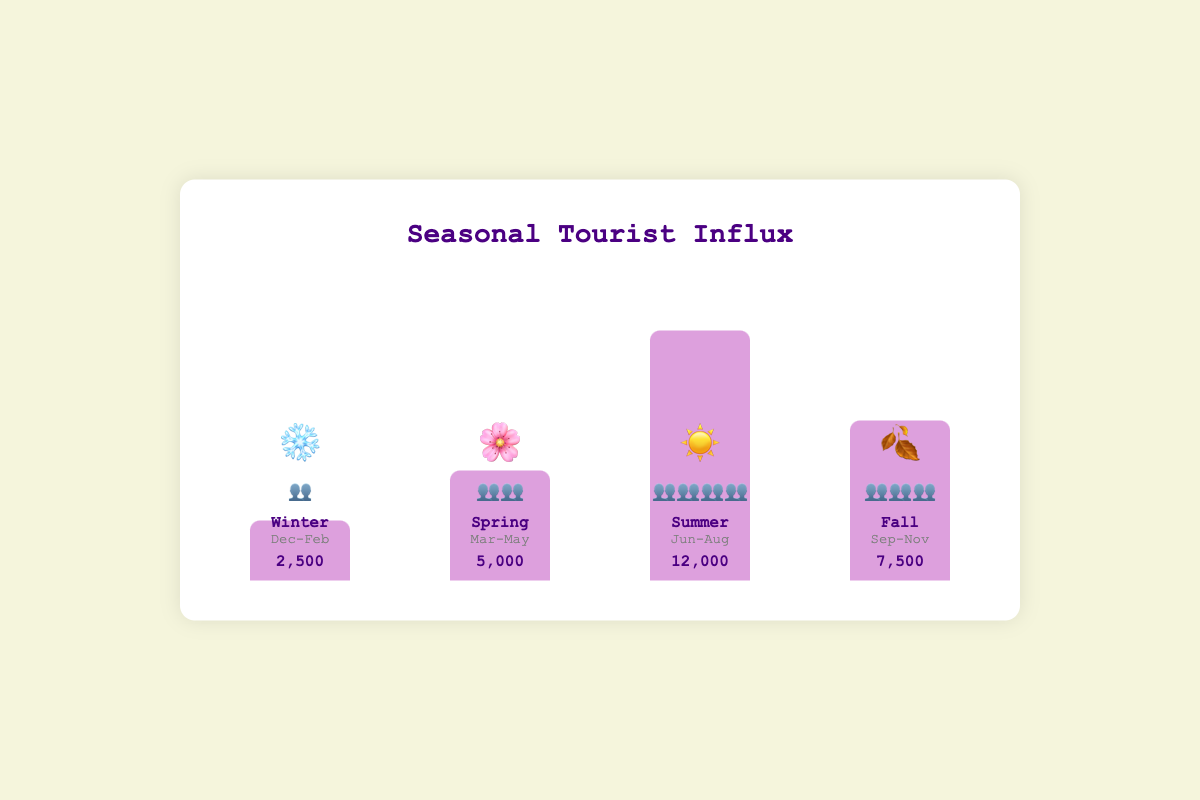What season has the highest number of tourists? The bar representing Summer has the highest height and shows 12,000 tourists, which is the highest among all seasons
Answer: Summer What is the weather emoji for Fall? The bar labeled Fall shows the weather as 🍂
Answer: 🍂 How many tourists visit during Winter? The Winter bar displays a number of 2,500 tourists
Answer: 2,500 Which season has more tourists, Spring or Fall? The Spring bar shows 5,000 tourists, whereas the Fall bar shows 7,500 tourists. Comparing these numbers, Fall has more tourists
Answer: Fall What is the total number of tourists across all seasons? Adding the number of tourists from each season: Winter (2,500) + Spring (5,000) + Summer (12,000) + Fall (7,500) gives us 27,000
Answer: 27,000 What is the average number of tourists per season? The sum of tourists for all seasons is 27,000. Dividing by 4 seasons gives 27,000 / 4 = 6,750 tourists on average per season
Answer: 6,750 Which season has the least crowd representation? The Winter bar has the least number of crowd emojis, showing only one emoji (👥), compared to other seasons
Answer: Winter How does the tourist number in Summer compare to Spring? Summer has 12,000 tourists while Spring has 5,000 tourists. Summer has 7,000 more tourists than Spring
Answer: Summer has 7,000 more What is the difference in tourists between the most and the least crowded seasons? The most crowded season is Summer (12,000 tourists) and the least crowded is Winter (2,500 tourists). The difference is 12,000 - 2,500 = 9,500
Answer: 9,500 How many crowd emojis are used to represent the Summer season? The Summer bar shows four crowd emojis (👥👥👥👥)
Answer: 4 